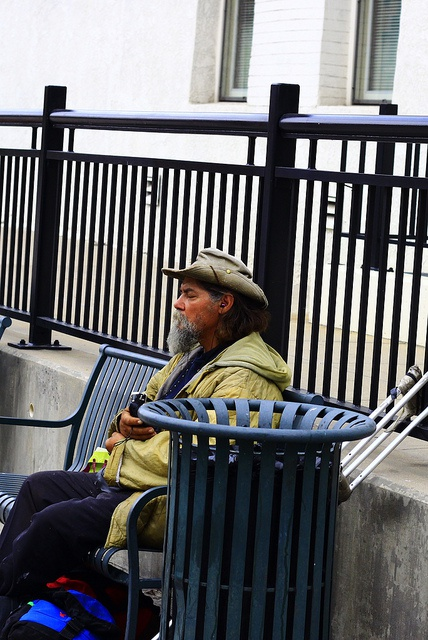Describe the objects in this image and their specific colors. I can see people in white, black, tan, darkgray, and olive tones, bench in white, black, darkgray, and gray tones, and backpack in white, black, blue, and navy tones in this image. 